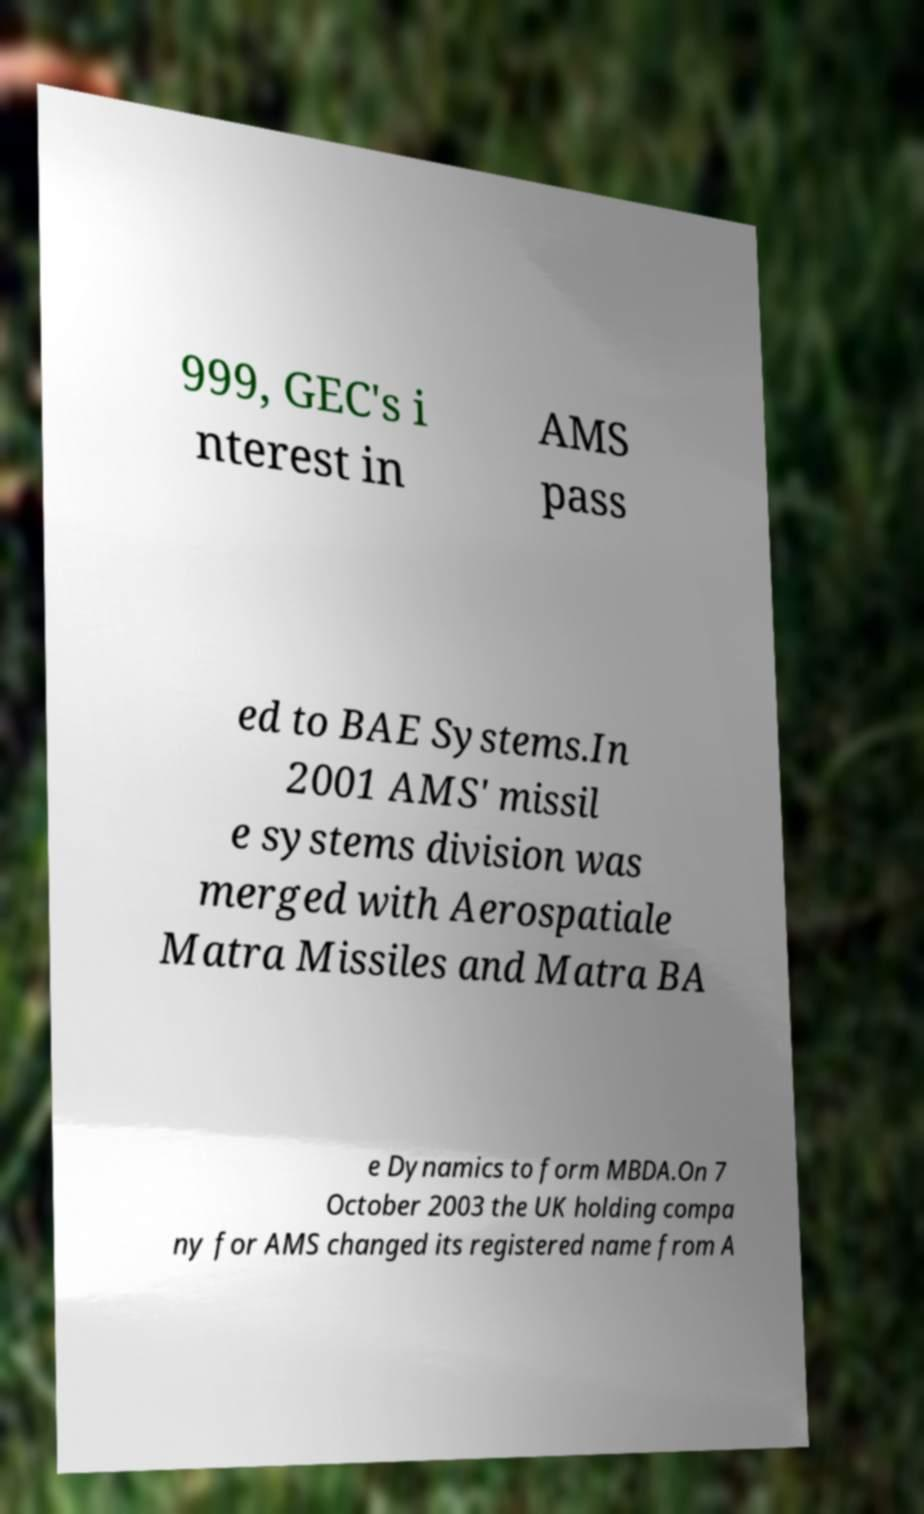Can you read and provide the text displayed in the image?This photo seems to have some interesting text. Can you extract and type it out for me? 999, GEC's i nterest in AMS pass ed to BAE Systems.In 2001 AMS' missil e systems division was merged with Aerospatiale Matra Missiles and Matra BA e Dynamics to form MBDA.On 7 October 2003 the UK holding compa ny for AMS changed its registered name from A 